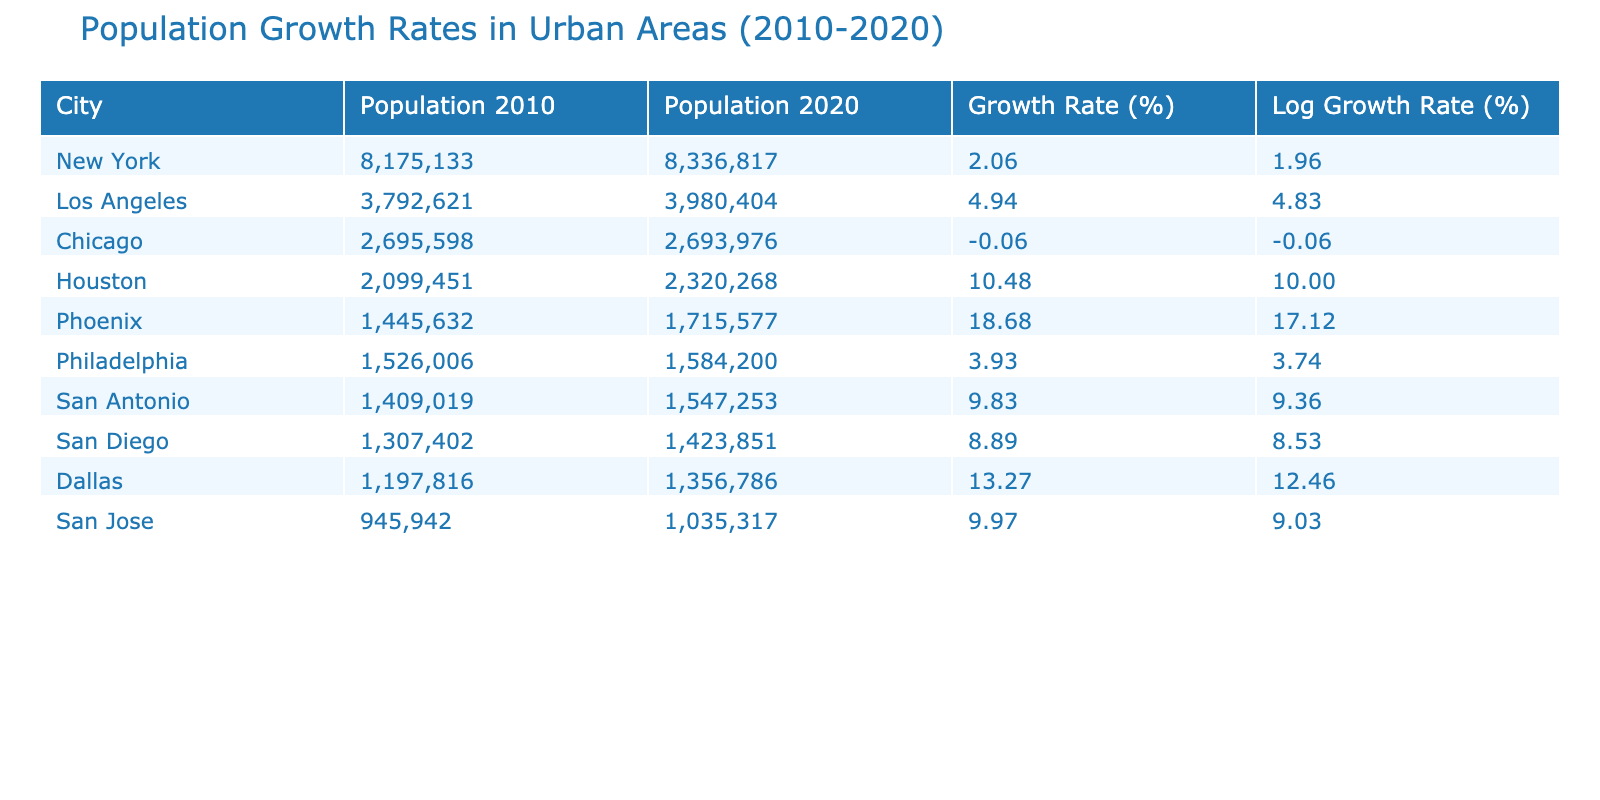What is the population of Phoenix in 2020? The population of Phoenix in 2020 is listed in the table under the column "Population 2020" which specifically shows the value for Phoenix as 1,715,577.
Answer: 1,715,577 What is the growth rate of Chicago? The growth rate of Chicago can be found in the "Growth Rate" column associated with Chicago in the table, indicating a growth rate of -0.06%.
Answer: -0.06% Which city experienced the highest growth rate between 2010 and 2020? The growth rates for all cities are compared, with Houston showing the highest growth rate of 10.48%.
Answer: Houston What is the average growth rate of all the cities listed? To find the average growth rate, we sum all growth rates and then divide by the number of cities. The sum is (2.06 + 4.94 - 0.06 + 10.48 + 18.68 + 3.93 + 9.83 + 8.89 + 13.27 + 9.97) = 81.99. Dividing by 10 gives an average of 8.199%.
Answer: 8.199 Did any city have a negative growth rate? The table shows that Chicago has a growth rate of -0.06%, indicating it did indeed experience negative growth.
Answer: Yes Which two cities had similar populations in 2010 and what were their respective growth rates? Chicago and Philadelphia had populations of 2,695,598 and 1,526,006, respectively. Their growth rates were -0.06% for Chicago and 3.93% for Philadelphia.
Answer: Chicago: -0.06%, Philadelphia: 3.93% How much did the population of Los Angeles increase in absolute numbers? To calculate the increase, subtract the population in 2010 from the population in 2020: 3,980,404 (2020) - 3,792,621 (2010) = 187,783.
Answer: 187,783 Which city had a log growth rate closest to 10%? By evaluating the logarithmic growth rates, Houston's logarithmic growth rate is 10.48%, making it the closest to 10%.
Answer: Houston What is the lowest logarithmic growth rate among the cities listed? Looking at the "Log Growth Rate" column, the lowest value can be determined from the data, which is -0.06% for Chicago.
Answer: -0.06% 